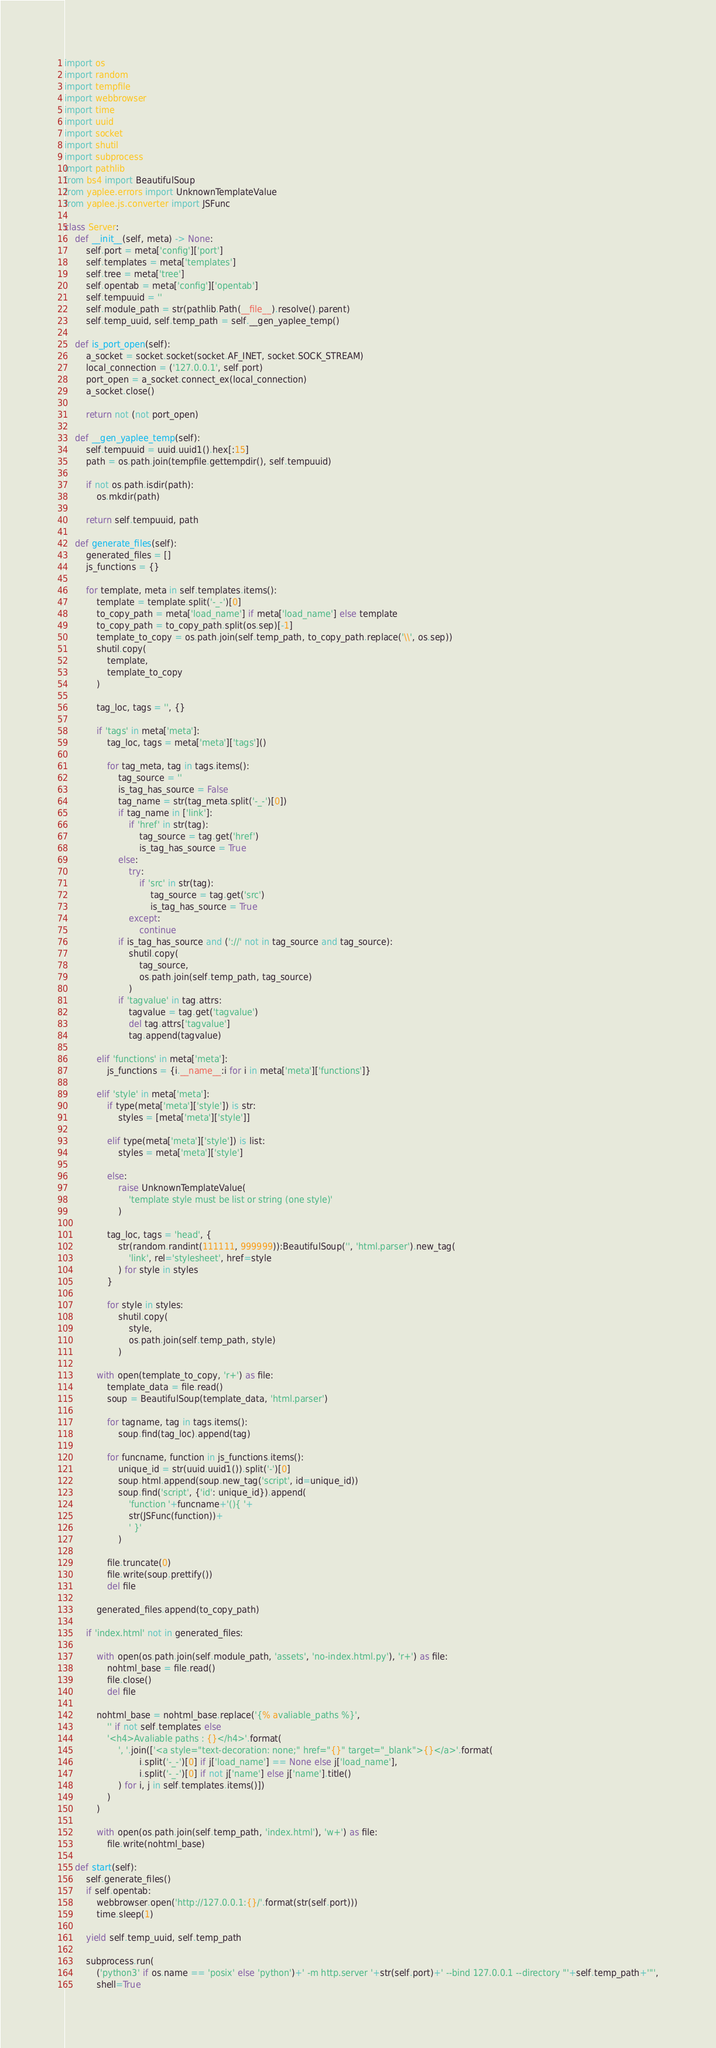<code> <loc_0><loc_0><loc_500><loc_500><_Python_>import os
import random
import tempfile
import webbrowser
import time
import uuid
import socket
import shutil
import subprocess
import pathlib
from bs4 import BeautifulSoup
from yaplee.errors import UnknownTemplateValue
from yaplee.js.converter import JSFunc

class Server:
    def __init__(self, meta) -> None:
        self.port = meta['config']['port']
        self.templates = meta['templates']
        self.tree = meta['tree']
        self.opentab = meta['config']['opentab']
        self.tempuuid = ''
        self.module_path = str(pathlib.Path(__file__).resolve().parent)
        self.temp_uuid, self.temp_path = self.__gen_yaplee_temp()

    def is_port_open(self):
        a_socket = socket.socket(socket.AF_INET, socket.SOCK_STREAM)
        local_connection = ('127.0.0.1', self.port)
        port_open = a_socket.connect_ex(local_connection)
        a_socket.close()

        return not (not port_open)

    def __gen_yaplee_temp(self):
        self.tempuuid = uuid.uuid1().hex[:15]
        path = os.path.join(tempfile.gettempdir(), self.tempuuid)

        if not os.path.isdir(path):
            os.mkdir(path)

        return self.tempuuid, path
    
    def generate_files(self):
        generated_files = []
        js_functions = {}

        for template, meta in self.templates.items():
            template = template.split('-_-')[0]
            to_copy_path = meta['load_name'] if meta['load_name'] else template
            to_copy_path = to_copy_path.split(os.sep)[-1]
            template_to_copy = os.path.join(self.temp_path, to_copy_path.replace('\\', os.sep))
            shutil.copy(
                template,
                template_to_copy
            )

            tag_loc, tags = '', {}

            if 'tags' in meta['meta']:
                tag_loc, tags = meta['meta']['tags']()

                for tag_meta, tag in tags.items():
                    tag_source = ''
                    is_tag_has_source = False
                    tag_name = str(tag_meta.split('-_-')[0])
                    if tag_name in ['link']:
                        if 'href' in str(tag):
                            tag_source = tag.get('href')
                            is_tag_has_source = True
                    else:
                        try:
                            if 'src' in str(tag):
                                tag_source = tag.get('src')
                                is_tag_has_source = True
                        except:
                            continue
                    if is_tag_has_source and ('://' not in tag_source and tag_source):
                        shutil.copy(
                            tag_source,
                            os.path.join(self.temp_path, tag_source)
                        )
                    if 'tagvalue' in tag.attrs:
                        tagvalue = tag.get('tagvalue')
                        del tag.attrs['tagvalue']
                        tag.append(tagvalue)

            elif 'functions' in meta['meta']:
                js_functions = {i.__name__:i for i in meta['meta']['functions']}

            elif 'style' in meta['meta']:
                if type(meta['meta']['style']) is str:
                    styles = [meta['meta']['style']]

                elif type(meta['meta']['style']) is list:
                    styles = meta['meta']['style']

                else:
                    raise UnknownTemplateValue(
                        'template style must be list or string (one style)'
                    )

                tag_loc, tags = 'head', {
                    str(random.randint(111111, 999999)):BeautifulSoup('', 'html.parser').new_tag(
                        'link', rel='stylesheet', href=style
                    ) for style in styles
                }

                for style in styles:
                    shutil.copy(
                        style,
                        os.path.join(self.temp_path, style)
                    )

            with open(template_to_copy, 'r+') as file:
                template_data = file.read()
                soup = BeautifulSoup(template_data, 'html.parser')

                for tagname, tag in tags.items():
                    soup.find(tag_loc).append(tag)

                for funcname, function in js_functions.items():
                    unique_id = str(uuid.uuid1()).split('-')[0]
                    soup.html.append(soup.new_tag('script', id=unique_id))
                    soup.find('script', {'id': unique_id}).append(
                        'function '+funcname+'(){ '+
                        str(JSFunc(function))+
                        ' }'
                    )

                file.truncate(0)
                file.write(soup.prettify())
                del file

            generated_files.append(to_copy_path)

        if 'index.html' not in generated_files:

            with open(os.path.join(self.module_path, 'assets', 'no-index.html.py'), 'r+') as file:
                nohtml_base = file.read()
                file.close()
                del file

            nohtml_base = nohtml_base.replace('{% avaliable_paths %}',
                '' if not self.templates else
                '<h4>Avaliable paths : {}</h4>'.format(
                    ', '.join(['<a style="text-decoration: none;" href="{}" target="_blank">{}</a>'.format(
                            i.split('-_-')[0] if j['load_name'] == None else j['load_name'],
                            i.split('-_-')[0] if not j['name'] else j['name'].title()
                    ) for i, j in self.templates.items()])
                )
            )

            with open(os.path.join(self.temp_path, 'index.html'), 'w+') as file:
                file.write(nohtml_base)

    def start(self):
        self.generate_files()
        if self.opentab:
            webbrowser.open('http://127.0.0.1:{}/'.format(str(self.port)))
            time.sleep(1)

        yield self.temp_uuid, self.temp_path
        
        subprocess.run(
            ('python3' if os.name == 'posix' else 'python')+' -m http.server '+str(self.port)+' --bind 127.0.0.1 --directory "'+self.temp_path+'"',
            shell=True</code> 